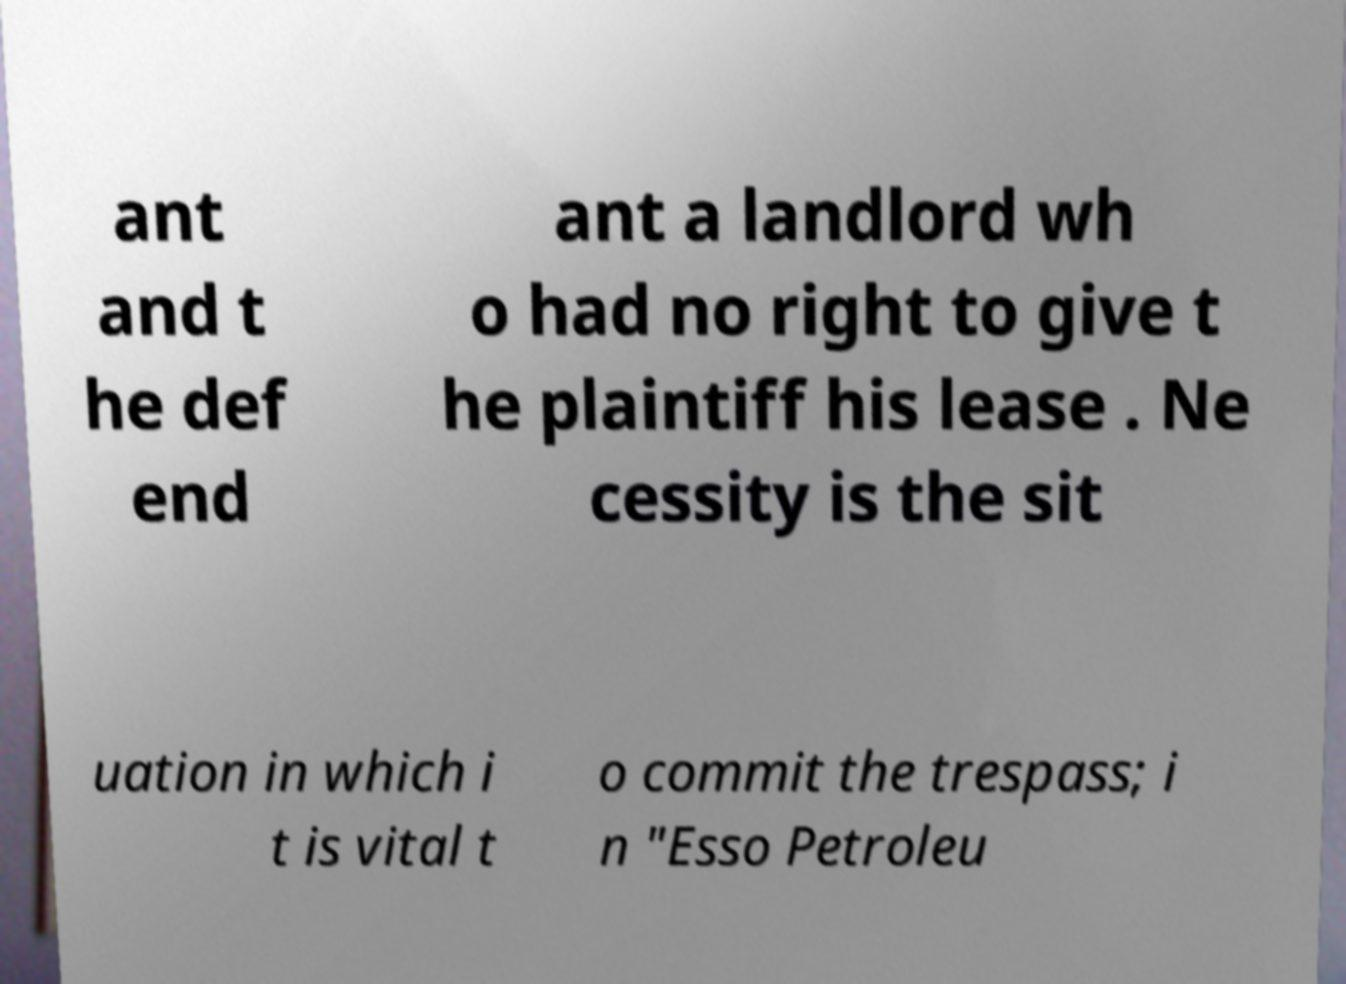There's text embedded in this image that I need extracted. Can you transcribe it verbatim? ant and t he def end ant a landlord wh o had no right to give t he plaintiff his lease . Ne cessity is the sit uation in which i t is vital t o commit the trespass; i n "Esso Petroleu 